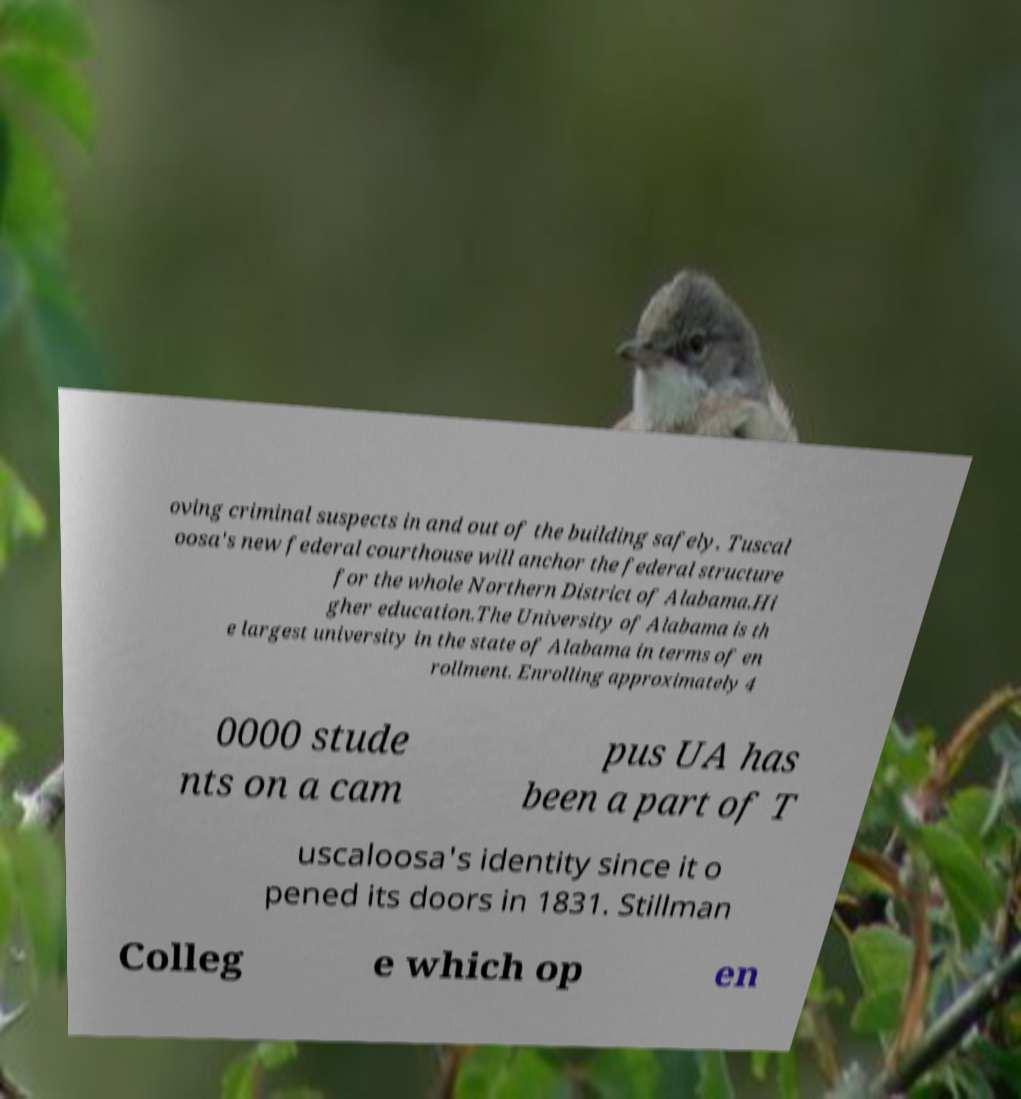Please identify and transcribe the text found in this image. oving criminal suspects in and out of the building safely. Tuscal oosa's new federal courthouse will anchor the federal structure for the whole Northern District of Alabama.Hi gher education.The University of Alabama is th e largest university in the state of Alabama in terms of en rollment. Enrolling approximately 4 0000 stude nts on a cam pus UA has been a part of T uscaloosa's identity since it o pened its doors in 1831. Stillman Colleg e which op en 